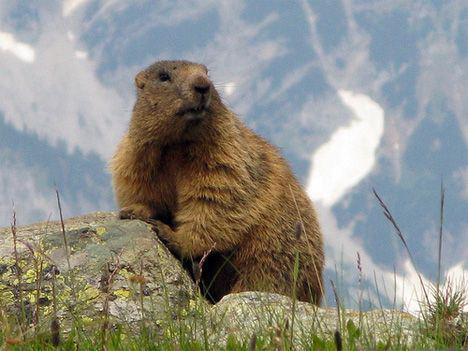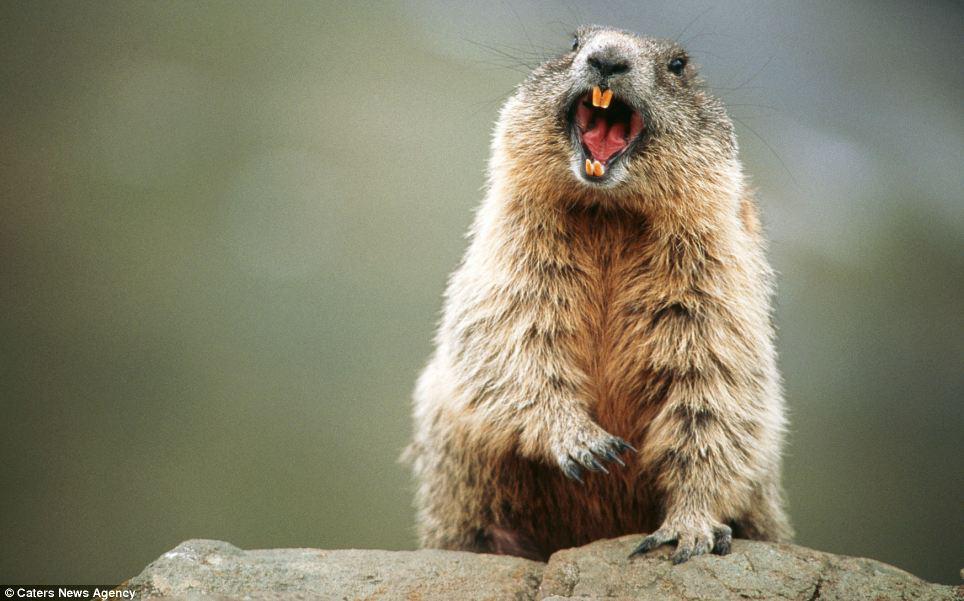The first image is the image on the left, the second image is the image on the right. For the images displayed, is the sentence "Two animals are playing with each other in the image on the right." factually correct? Answer yes or no. No. 